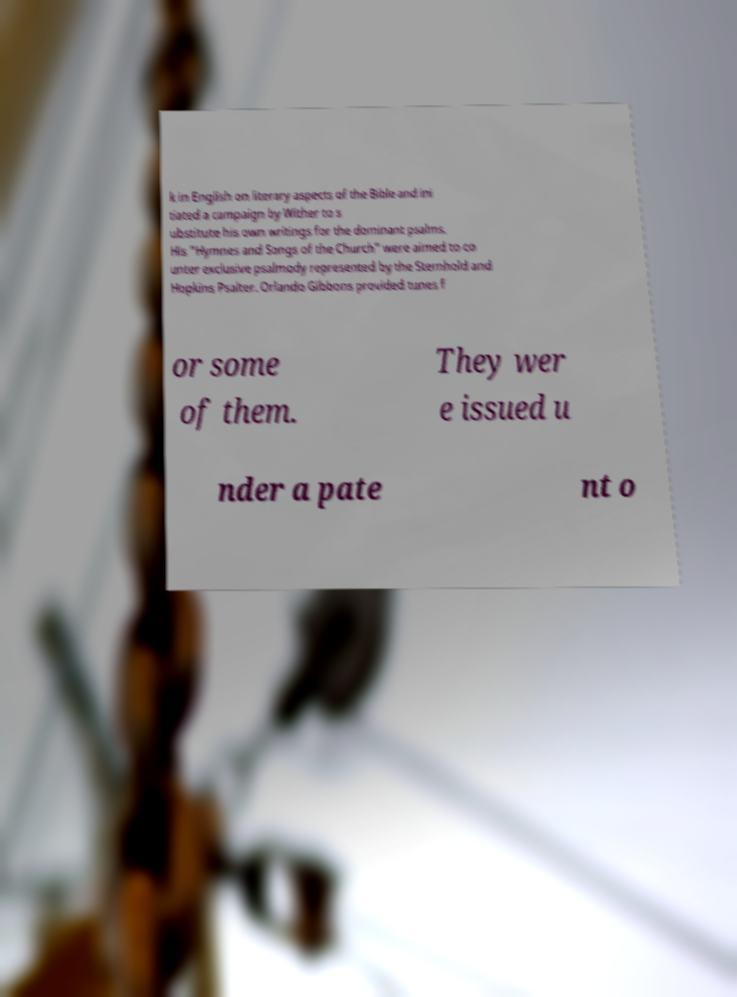What messages or text are displayed in this image? I need them in a readable, typed format. k in English on literary aspects of the Bible and ini tiated a campaign by Wither to s ubstitute his own writings for the dominant psalms. His "Hymnes and Songs of the Church" were aimed to co unter exclusive psalmody represented by the Sternhold and Hopkins Psalter. Orlando Gibbons provided tunes f or some of them. They wer e issued u nder a pate nt o 